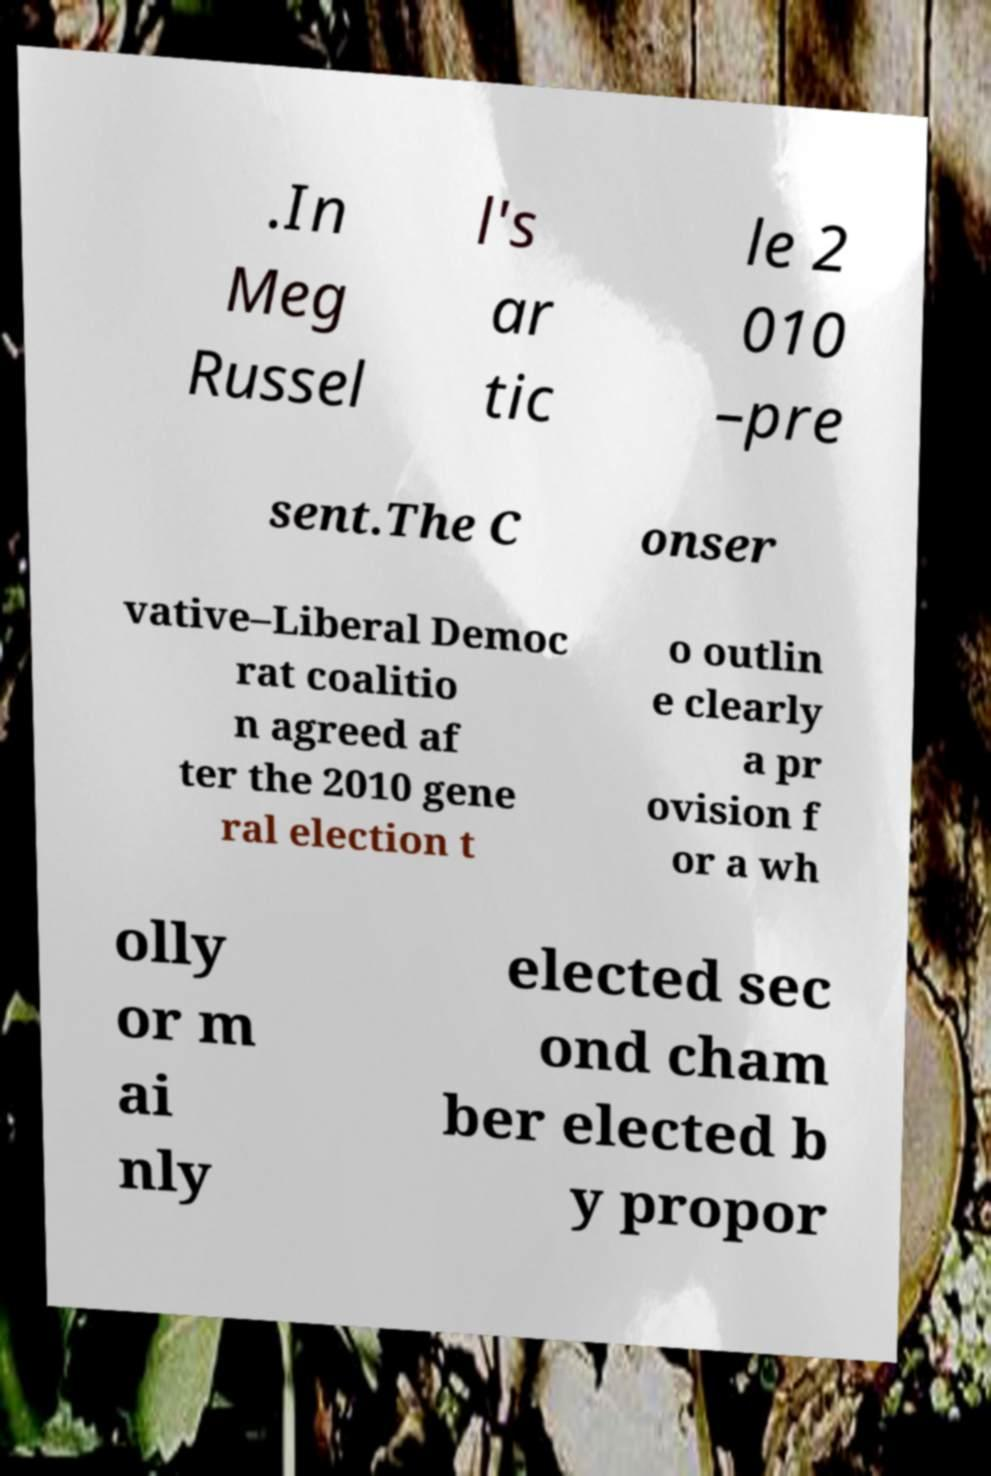There's text embedded in this image that I need extracted. Can you transcribe it verbatim? .In Meg Russel l's ar tic le 2 010 –pre sent.The C onser vative–Liberal Democ rat coalitio n agreed af ter the 2010 gene ral election t o outlin e clearly a pr ovision f or a wh olly or m ai nly elected sec ond cham ber elected b y propor 